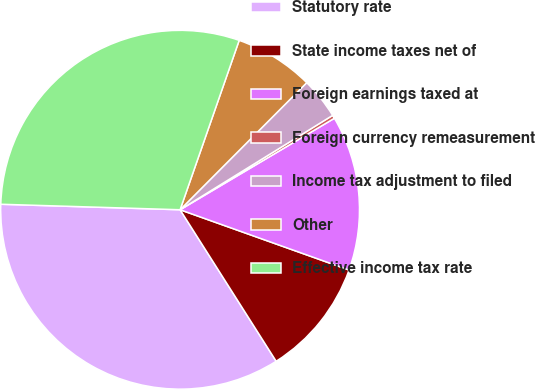Convert chart to OTSL. <chart><loc_0><loc_0><loc_500><loc_500><pie_chart><fcel>Statutory rate<fcel>State income taxes net of<fcel>Foreign earnings taxed at<fcel>Foreign currency remeasurement<fcel>Income tax adjustment to filed<fcel>Other<fcel>Effective income tax rate<nl><fcel>34.48%<fcel>10.55%<fcel>13.97%<fcel>0.3%<fcel>3.71%<fcel>7.13%<fcel>29.85%<nl></chart> 